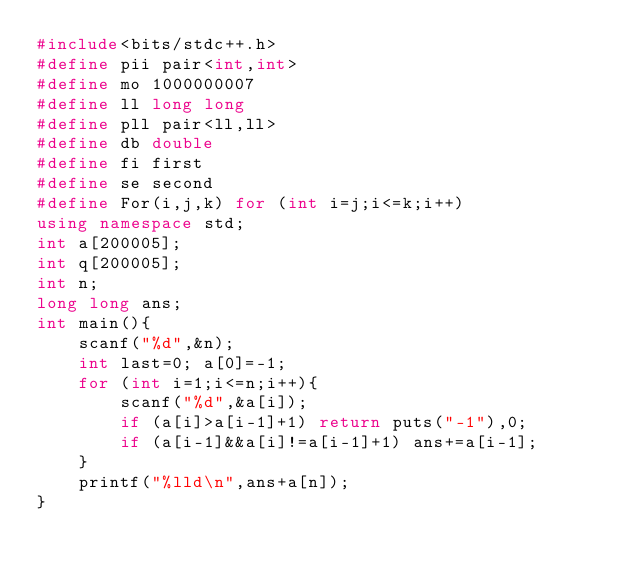<code> <loc_0><loc_0><loc_500><loc_500><_C++_>#include<bits/stdc++.h>
#define pii pair<int,int>
#define mo 1000000007
#define ll long long
#define pll pair<ll,ll>
#define db double
#define fi first
#define se second
#define For(i,j,k) for (int i=j;i<=k;i++)
using namespace std;
int a[200005];
int q[200005];
int n;
long long ans;
int main(){
	scanf("%d",&n);
	int last=0; a[0]=-1;
	for (int i=1;i<=n;i++){
		scanf("%d",&a[i]);
		if (a[i]>a[i-1]+1) return puts("-1"),0;
		if (a[i-1]&&a[i]!=a[i-1]+1) ans+=a[i-1];
	}
	printf("%lld\n",ans+a[n]);
}</code> 